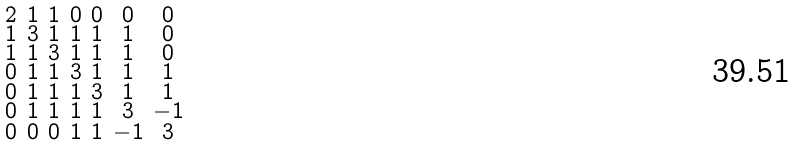<formula> <loc_0><loc_0><loc_500><loc_500>\begin{smallmatrix} 2 & 1 & 1 & 0 & 0 & 0 & 0 \\ 1 & 3 & 1 & 1 & 1 & 1 & 0 \\ 1 & 1 & 3 & 1 & 1 & 1 & 0 \\ 0 & 1 & 1 & 3 & 1 & 1 & 1 \\ 0 & 1 & 1 & 1 & 3 & 1 & 1 \\ 0 & 1 & 1 & 1 & 1 & 3 & - 1 \\ 0 & 0 & 0 & 1 & 1 & - 1 & 3 \end{smallmatrix}</formula> 